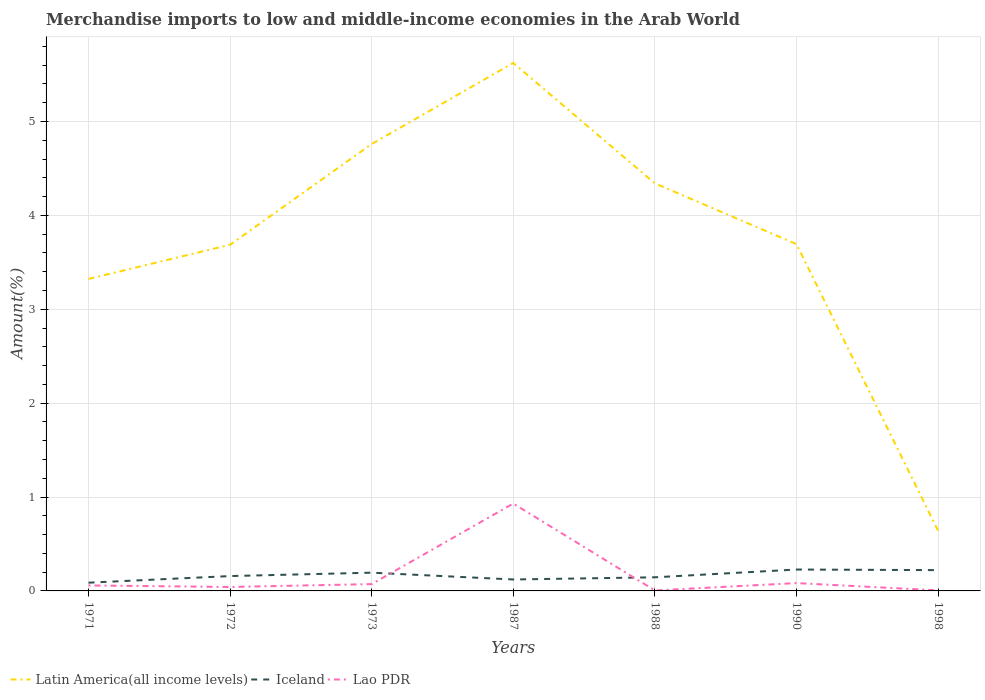Does the line corresponding to Iceland intersect with the line corresponding to Latin America(all income levels)?
Offer a very short reply. No. Across all years, what is the maximum percentage of amount earned from merchandise imports in Latin America(all income levels)?
Your response must be concise. 0.64. What is the total percentage of amount earned from merchandise imports in Lao PDR in the graph?
Your response must be concise. 0.04. What is the difference between the highest and the second highest percentage of amount earned from merchandise imports in Latin America(all income levels)?
Your answer should be compact. 4.98. Is the percentage of amount earned from merchandise imports in Latin America(all income levels) strictly greater than the percentage of amount earned from merchandise imports in Lao PDR over the years?
Keep it short and to the point. No. How many years are there in the graph?
Keep it short and to the point. 7. What is the difference between two consecutive major ticks on the Y-axis?
Make the answer very short. 1. Does the graph contain any zero values?
Keep it short and to the point. No. How are the legend labels stacked?
Give a very brief answer. Horizontal. What is the title of the graph?
Give a very brief answer. Merchandise imports to low and middle-income economies in the Arab World. Does "Mexico" appear as one of the legend labels in the graph?
Provide a short and direct response. No. What is the label or title of the X-axis?
Give a very brief answer. Years. What is the label or title of the Y-axis?
Your response must be concise. Amount(%). What is the Amount(%) of Latin America(all income levels) in 1971?
Give a very brief answer. 3.32. What is the Amount(%) of Iceland in 1971?
Provide a succinct answer. 0.09. What is the Amount(%) of Lao PDR in 1971?
Give a very brief answer. 0.06. What is the Amount(%) of Latin America(all income levels) in 1972?
Your answer should be compact. 3.69. What is the Amount(%) in Iceland in 1972?
Provide a succinct answer. 0.16. What is the Amount(%) in Lao PDR in 1972?
Offer a very short reply. 0.04. What is the Amount(%) of Latin America(all income levels) in 1973?
Provide a succinct answer. 4.76. What is the Amount(%) of Iceland in 1973?
Offer a very short reply. 0.19. What is the Amount(%) in Lao PDR in 1973?
Your answer should be compact. 0.07. What is the Amount(%) of Latin America(all income levels) in 1987?
Keep it short and to the point. 5.62. What is the Amount(%) in Iceland in 1987?
Your response must be concise. 0.12. What is the Amount(%) of Lao PDR in 1987?
Provide a succinct answer. 0.93. What is the Amount(%) in Latin America(all income levels) in 1988?
Ensure brevity in your answer.  4.34. What is the Amount(%) of Iceland in 1988?
Provide a short and direct response. 0.15. What is the Amount(%) of Lao PDR in 1988?
Provide a short and direct response. 0. What is the Amount(%) in Latin America(all income levels) in 1990?
Your answer should be compact. 3.69. What is the Amount(%) in Iceland in 1990?
Your response must be concise. 0.23. What is the Amount(%) in Lao PDR in 1990?
Your response must be concise. 0.08. What is the Amount(%) in Latin America(all income levels) in 1998?
Offer a terse response. 0.64. What is the Amount(%) in Iceland in 1998?
Your answer should be compact. 0.22. What is the Amount(%) in Lao PDR in 1998?
Offer a very short reply. 0.01. Across all years, what is the maximum Amount(%) of Latin America(all income levels)?
Your answer should be compact. 5.62. Across all years, what is the maximum Amount(%) of Iceland?
Offer a terse response. 0.23. Across all years, what is the maximum Amount(%) in Lao PDR?
Offer a terse response. 0.93. Across all years, what is the minimum Amount(%) in Latin America(all income levels)?
Your response must be concise. 0.64. Across all years, what is the minimum Amount(%) in Iceland?
Your answer should be compact. 0.09. Across all years, what is the minimum Amount(%) in Lao PDR?
Your answer should be compact. 0. What is the total Amount(%) in Latin America(all income levels) in the graph?
Provide a short and direct response. 26.07. What is the total Amount(%) of Iceland in the graph?
Your answer should be very brief. 1.16. What is the total Amount(%) of Lao PDR in the graph?
Provide a short and direct response. 1.2. What is the difference between the Amount(%) of Latin America(all income levels) in 1971 and that in 1972?
Give a very brief answer. -0.36. What is the difference between the Amount(%) of Iceland in 1971 and that in 1972?
Your answer should be very brief. -0.07. What is the difference between the Amount(%) in Lao PDR in 1971 and that in 1972?
Offer a very short reply. 0.02. What is the difference between the Amount(%) in Latin America(all income levels) in 1971 and that in 1973?
Give a very brief answer. -1.44. What is the difference between the Amount(%) of Iceland in 1971 and that in 1973?
Ensure brevity in your answer.  -0.11. What is the difference between the Amount(%) in Lao PDR in 1971 and that in 1973?
Provide a short and direct response. -0.01. What is the difference between the Amount(%) of Latin America(all income levels) in 1971 and that in 1987?
Provide a short and direct response. -2.3. What is the difference between the Amount(%) in Iceland in 1971 and that in 1987?
Offer a terse response. -0.03. What is the difference between the Amount(%) of Lao PDR in 1971 and that in 1987?
Your answer should be very brief. -0.87. What is the difference between the Amount(%) in Latin America(all income levels) in 1971 and that in 1988?
Keep it short and to the point. -1.02. What is the difference between the Amount(%) of Iceland in 1971 and that in 1988?
Provide a short and direct response. -0.06. What is the difference between the Amount(%) of Lao PDR in 1971 and that in 1988?
Your answer should be very brief. 0.05. What is the difference between the Amount(%) in Latin America(all income levels) in 1971 and that in 1990?
Offer a terse response. -0.37. What is the difference between the Amount(%) of Iceland in 1971 and that in 1990?
Your answer should be compact. -0.14. What is the difference between the Amount(%) of Lao PDR in 1971 and that in 1990?
Provide a succinct answer. -0.03. What is the difference between the Amount(%) in Latin America(all income levels) in 1971 and that in 1998?
Provide a succinct answer. 2.68. What is the difference between the Amount(%) of Iceland in 1971 and that in 1998?
Your answer should be very brief. -0.13. What is the difference between the Amount(%) in Lao PDR in 1971 and that in 1998?
Your answer should be compact. 0.05. What is the difference between the Amount(%) of Latin America(all income levels) in 1972 and that in 1973?
Your answer should be very brief. -1.07. What is the difference between the Amount(%) in Iceland in 1972 and that in 1973?
Provide a short and direct response. -0.04. What is the difference between the Amount(%) of Lao PDR in 1972 and that in 1973?
Keep it short and to the point. -0.03. What is the difference between the Amount(%) in Latin America(all income levels) in 1972 and that in 1987?
Provide a short and direct response. -1.94. What is the difference between the Amount(%) in Iceland in 1972 and that in 1987?
Your response must be concise. 0.04. What is the difference between the Amount(%) of Lao PDR in 1972 and that in 1987?
Keep it short and to the point. -0.89. What is the difference between the Amount(%) in Latin America(all income levels) in 1972 and that in 1988?
Ensure brevity in your answer.  -0.65. What is the difference between the Amount(%) in Iceland in 1972 and that in 1988?
Your answer should be very brief. 0.01. What is the difference between the Amount(%) in Lao PDR in 1972 and that in 1988?
Provide a succinct answer. 0.04. What is the difference between the Amount(%) in Latin America(all income levels) in 1972 and that in 1990?
Your answer should be very brief. -0.01. What is the difference between the Amount(%) of Iceland in 1972 and that in 1990?
Offer a terse response. -0.07. What is the difference between the Amount(%) in Lao PDR in 1972 and that in 1990?
Give a very brief answer. -0.04. What is the difference between the Amount(%) of Latin America(all income levels) in 1972 and that in 1998?
Your answer should be compact. 3.04. What is the difference between the Amount(%) of Iceland in 1972 and that in 1998?
Ensure brevity in your answer.  -0.06. What is the difference between the Amount(%) of Lao PDR in 1972 and that in 1998?
Give a very brief answer. 0.04. What is the difference between the Amount(%) in Latin America(all income levels) in 1973 and that in 1987?
Offer a terse response. -0.86. What is the difference between the Amount(%) of Iceland in 1973 and that in 1987?
Provide a short and direct response. 0.07. What is the difference between the Amount(%) of Lao PDR in 1973 and that in 1987?
Your answer should be compact. -0.86. What is the difference between the Amount(%) in Latin America(all income levels) in 1973 and that in 1988?
Keep it short and to the point. 0.42. What is the difference between the Amount(%) of Iceland in 1973 and that in 1988?
Keep it short and to the point. 0.05. What is the difference between the Amount(%) in Lao PDR in 1973 and that in 1988?
Your response must be concise. 0.07. What is the difference between the Amount(%) in Latin America(all income levels) in 1973 and that in 1990?
Offer a very short reply. 1.07. What is the difference between the Amount(%) in Iceland in 1973 and that in 1990?
Ensure brevity in your answer.  -0.03. What is the difference between the Amount(%) of Lao PDR in 1973 and that in 1990?
Make the answer very short. -0.01. What is the difference between the Amount(%) in Latin America(all income levels) in 1973 and that in 1998?
Provide a short and direct response. 4.12. What is the difference between the Amount(%) in Iceland in 1973 and that in 1998?
Your answer should be very brief. -0.03. What is the difference between the Amount(%) in Lao PDR in 1973 and that in 1998?
Give a very brief answer. 0.07. What is the difference between the Amount(%) in Latin America(all income levels) in 1987 and that in 1988?
Provide a succinct answer. 1.28. What is the difference between the Amount(%) in Iceland in 1987 and that in 1988?
Give a very brief answer. -0.02. What is the difference between the Amount(%) of Lao PDR in 1987 and that in 1988?
Keep it short and to the point. 0.93. What is the difference between the Amount(%) in Latin America(all income levels) in 1987 and that in 1990?
Your answer should be compact. 1.93. What is the difference between the Amount(%) in Iceland in 1987 and that in 1990?
Offer a very short reply. -0.11. What is the difference between the Amount(%) in Lao PDR in 1987 and that in 1990?
Ensure brevity in your answer.  0.85. What is the difference between the Amount(%) in Latin America(all income levels) in 1987 and that in 1998?
Provide a short and direct response. 4.98. What is the difference between the Amount(%) of Iceland in 1987 and that in 1998?
Offer a terse response. -0.1. What is the difference between the Amount(%) in Lao PDR in 1987 and that in 1998?
Provide a succinct answer. 0.92. What is the difference between the Amount(%) in Latin America(all income levels) in 1988 and that in 1990?
Your answer should be very brief. 0.65. What is the difference between the Amount(%) in Iceland in 1988 and that in 1990?
Provide a short and direct response. -0.08. What is the difference between the Amount(%) in Lao PDR in 1988 and that in 1990?
Offer a terse response. -0.08. What is the difference between the Amount(%) in Latin America(all income levels) in 1988 and that in 1998?
Your answer should be very brief. 3.7. What is the difference between the Amount(%) of Iceland in 1988 and that in 1998?
Keep it short and to the point. -0.08. What is the difference between the Amount(%) of Lao PDR in 1988 and that in 1998?
Your answer should be very brief. -0. What is the difference between the Amount(%) in Latin America(all income levels) in 1990 and that in 1998?
Provide a succinct answer. 3.05. What is the difference between the Amount(%) of Iceland in 1990 and that in 1998?
Offer a terse response. 0.01. What is the difference between the Amount(%) in Lao PDR in 1990 and that in 1998?
Provide a short and direct response. 0.08. What is the difference between the Amount(%) in Latin America(all income levels) in 1971 and the Amount(%) in Iceland in 1972?
Make the answer very short. 3.16. What is the difference between the Amount(%) of Latin America(all income levels) in 1971 and the Amount(%) of Lao PDR in 1972?
Give a very brief answer. 3.28. What is the difference between the Amount(%) in Iceland in 1971 and the Amount(%) in Lao PDR in 1972?
Make the answer very short. 0.05. What is the difference between the Amount(%) of Latin America(all income levels) in 1971 and the Amount(%) of Iceland in 1973?
Offer a very short reply. 3.13. What is the difference between the Amount(%) of Latin America(all income levels) in 1971 and the Amount(%) of Lao PDR in 1973?
Ensure brevity in your answer.  3.25. What is the difference between the Amount(%) of Iceland in 1971 and the Amount(%) of Lao PDR in 1973?
Your response must be concise. 0.01. What is the difference between the Amount(%) in Latin America(all income levels) in 1971 and the Amount(%) in Iceland in 1987?
Offer a very short reply. 3.2. What is the difference between the Amount(%) of Latin America(all income levels) in 1971 and the Amount(%) of Lao PDR in 1987?
Your answer should be very brief. 2.39. What is the difference between the Amount(%) of Iceland in 1971 and the Amount(%) of Lao PDR in 1987?
Ensure brevity in your answer.  -0.84. What is the difference between the Amount(%) in Latin America(all income levels) in 1971 and the Amount(%) in Iceland in 1988?
Make the answer very short. 3.18. What is the difference between the Amount(%) in Latin America(all income levels) in 1971 and the Amount(%) in Lao PDR in 1988?
Your response must be concise. 3.32. What is the difference between the Amount(%) in Iceland in 1971 and the Amount(%) in Lao PDR in 1988?
Offer a terse response. 0.08. What is the difference between the Amount(%) of Latin America(all income levels) in 1971 and the Amount(%) of Iceland in 1990?
Your answer should be very brief. 3.1. What is the difference between the Amount(%) in Latin America(all income levels) in 1971 and the Amount(%) in Lao PDR in 1990?
Ensure brevity in your answer.  3.24. What is the difference between the Amount(%) of Iceland in 1971 and the Amount(%) of Lao PDR in 1990?
Ensure brevity in your answer.  0. What is the difference between the Amount(%) in Latin America(all income levels) in 1971 and the Amount(%) in Iceland in 1998?
Give a very brief answer. 3.1. What is the difference between the Amount(%) in Latin America(all income levels) in 1971 and the Amount(%) in Lao PDR in 1998?
Keep it short and to the point. 3.32. What is the difference between the Amount(%) in Iceland in 1971 and the Amount(%) in Lao PDR in 1998?
Your response must be concise. 0.08. What is the difference between the Amount(%) of Latin America(all income levels) in 1972 and the Amount(%) of Iceland in 1973?
Provide a succinct answer. 3.49. What is the difference between the Amount(%) in Latin America(all income levels) in 1972 and the Amount(%) in Lao PDR in 1973?
Your answer should be very brief. 3.61. What is the difference between the Amount(%) of Iceland in 1972 and the Amount(%) of Lao PDR in 1973?
Provide a short and direct response. 0.09. What is the difference between the Amount(%) in Latin America(all income levels) in 1972 and the Amount(%) in Iceland in 1987?
Provide a succinct answer. 3.57. What is the difference between the Amount(%) in Latin America(all income levels) in 1972 and the Amount(%) in Lao PDR in 1987?
Your answer should be compact. 2.76. What is the difference between the Amount(%) in Iceland in 1972 and the Amount(%) in Lao PDR in 1987?
Give a very brief answer. -0.77. What is the difference between the Amount(%) of Latin America(all income levels) in 1972 and the Amount(%) of Iceland in 1988?
Offer a very short reply. 3.54. What is the difference between the Amount(%) in Latin America(all income levels) in 1972 and the Amount(%) in Lao PDR in 1988?
Your answer should be compact. 3.68. What is the difference between the Amount(%) of Iceland in 1972 and the Amount(%) of Lao PDR in 1988?
Your answer should be very brief. 0.15. What is the difference between the Amount(%) in Latin America(all income levels) in 1972 and the Amount(%) in Iceland in 1990?
Give a very brief answer. 3.46. What is the difference between the Amount(%) in Latin America(all income levels) in 1972 and the Amount(%) in Lao PDR in 1990?
Provide a succinct answer. 3.6. What is the difference between the Amount(%) in Iceland in 1972 and the Amount(%) in Lao PDR in 1990?
Your answer should be compact. 0.07. What is the difference between the Amount(%) in Latin America(all income levels) in 1972 and the Amount(%) in Iceland in 1998?
Provide a short and direct response. 3.47. What is the difference between the Amount(%) in Latin America(all income levels) in 1972 and the Amount(%) in Lao PDR in 1998?
Offer a very short reply. 3.68. What is the difference between the Amount(%) of Iceland in 1972 and the Amount(%) of Lao PDR in 1998?
Your response must be concise. 0.15. What is the difference between the Amount(%) of Latin America(all income levels) in 1973 and the Amount(%) of Iceland in 1987?
Make the answer very short. 4.64. What is the difference between the Amount(%) of Latin America(all income levels) in 1973 and the Amount(%) of Lao PDR in 1987?
Keep it short and to the point. 3.83. What is the difference between the Amount(%) of Iceland in 1973 and the Amount(%) of Lao PDR in 1987?
Offer a terse response. -0.74. What is the difference between the Amount(%) of Latin America(all income levels) in 1973 and the Amount(%) of Iceland in 1988?
Your answer should be compact. 4.62. What is the difference between the Amount(%) of Latin America(all income levels) in 1973 and the Amount(%) of Lao PDR in 1988?
Offer a terse response. 4.76. What is the difference between the Amount(%) of Iceland in 1973 and the Amount(%) of Lao PDR in 1988?
Ensure brevity in your answer.  0.19. What is the difference between the Amount(%) of Latin America(all income levels) in 1973 and the Amount(%) of Iceland in 1990?
Give a very brief answer. 4.53. What is the difference between the Amount(%) of Latin America(all income levels) in 1973 and the Amount(%) of Lao PDR in 1990?
Provide a succinct answer. 4.68. What is the difference between the Amount(%) of Iceland in 1973 and the Amount(%) of Lao PDR in 1990?
Your answer should be very brief. 0.11. What is the difference between the Amount(%) in Latin America(all income levels) in 1973 and the Amount(%) in Iceland in 1998?
Ensure brevity in your answer.  4.54. What is the difference between the Amount(%) in Latin America(all income levels) in 1973 and the Amount(%) in Lao PDR in 1998?
Your response must be concise. 4.75. What is the difference between the Amount(%) of Iceland in 1973 and the Amount(%) of Lao PDR in 1998?
Your answer should be compact. 0.19. What is the difference between the Amount(%) in Latin America(all income levels) in 1987 and the Amount(%) in Iceland in 1988?
Offer a very short reply. 5.48. What is the difference between the Amount(%) in Latin America(all income levels) in 1987 and the Amount(%) in Lao PDR in 1988?
Your answer should be compact. 5.62. What is the difference between the Amount(%) of Iceland in 1987 and the Amount(%) of Lao PDR in 1988?
Keep it short and to the point. 0.12. What is the difference between the Amount(%) of Latin America(all income levels) in 1987 and the Amount(%) of Iceland in 1990?
Ensure brevity in your answer.  5.4. What is the difference between the Amount(%) of Latin America(all income levels) in 1987 and the Amount(%) of Lao PDR in 1990?
Make the answer very short. 5.54. What is the difference between the Amount(%) in Iceland in 1987 and the Amount(%) in Lao PDR in 1990?
Make the answer very short. 0.04. What is the difference between the Amount(%) in Latin America(all income levels) in 1987 and the Amount(%) in Iceland in 1998?
Make the answer very short. 5.4. What is the difference between the Amount(%) of Latin America(all income levels) in 1987 and the Amount(%) of Lao PDR in 1998?
Offer a very short reply. 5.62. What is the difference between the Amount(%) in Iceland in 1987 and the Amount(%) in Lao PDR in 1998?
Your answer should be compact. 0.12. What is the difference between the Amount(%) of Latin America(all income levels) in 1988 and the Amount(%) of Iceland in 1990?
Provide a succinct answer. 4.11. What is the difference between the Amount(%) in Latin America(all income levels) in 1988 and the Amount(%) in Lao PDR in 1990?
Your response must be concise. 4.26. What is the difference between the Amount(%) in Iceland in 1988 and the Amount(%) in Lao PDR in 1990?
Your answer should be very brief. 0.06. What is the difference between the Amount(%) of Latin America(all income levels) in 1988 and the Amount(%) of Iceland in 1998?
Ensure brevity in your answer.  4.12. What is the difference between the Amount(%) of Latin America(all income levels) in 1988 and the Amount(%) of Lao PDR in 1998?
Keep it short and to the point. 4.34. What is the difference between the Amount(%) in Iceland in 1988 and the Amount(%) in Lao PDR in 1998?
Offer a terse response. 0.14. What is the difference between the Amount(%) in Latin America(all income levels) in 1990 and the Amount(%) in Iceland in 1998?
Your answer should be very brief. 3.47. What is the difference between the Amount(%) in Latin America(all income levels) in 1990 and the Amount(%) in Lao PDR in 1998?
Keep it short and to the point. 3.69. What is the difference between the Amount(%) of Iceland in 1990 and the Amount(%) of Lao PDR in 1998?
Offer a terse response. 0.22. What is the average Amount(%) of Latin America(all income levels) per year?
Your answer should be very brief. 3.72. What is the average Amount(%) in Iceland per year?
Your answer should be very brief. 0.17. What is the average Amount(%) in Lao PDR per year?
Keep it short and to the point. 0.17. In the year 1971, what is the difference between the Amount(%) in Latin America(all income levels) and Amount(%) in Iceland?
Provide a succinct answer. 3.24. In the year 1971, what is the difference between the Amount(%) of Latin America(all income levels) and Amount(%) of Lao PDR?
Your answer should be very brief. 3.26. In the year 1971, what is the difference between the Amount(%) in Iceland and Amount(%) in Lao PDR?
Your answer should be very brief. 0.03. In the year 1972, what is the difference between the Amount(%) in Latin America(all income levels) and Amount(%) in Iceland?
Ensure brevity in your answer.  3.53. In the year 1972, what is the difference between the Amount(%) of Latin America(all income levels) and Amount(%) of Lao PDR?
Your answer should be compact. 3.65. In the year 1972, what is the difference between the Amount(%) in Iceland and Amount(%) in Lao PDR?
Your answer should be very brief. 0.12. In the year 1973, what is the difference between the Amount(%) in Latin America(all income levels) and Amount(%) in Iceland?
Offer a terse response. 4.57. In the year 1973, what is the difference between the Amount(%) of Latin America(all income levels) and Amount(%) of Lao PDR?
Your response must be concise. 4.69. In the year 1973, what is the difference between the Amount(%) in Iceland and Amount(%) in Lao PDR?
Provide a short and direct response. 0.12. In the year 1987, what is the difference between the Amount(%) of Latin America(all income levels) and Amount(%) of Iceland?
Give a very brief answer. 5.5. In the year 1987, what is the difference between the Amount(%) of Latin America(all income levels) and Amount(%) of Lao PDR?
Offer a very short reply. 4.69. In the year 1987, what is the difference between the Amount(%) in Iceland and Amount(%) in Lao PDR?
Your response must be concise. -0.81. In the year 1988, what is the difference between the Amount(%) in Latin America(all income levels) and Amount(%) in Iceland?
Provide a succinct answer. 4.2. In the year 1988, what is the difference between the Amount(%) in Latin America(all income levels) and Amount(%) in Lao PDR?
Your answer should be very brief. 4.34. In the year 1988, what is the difference between the Amount(%) of Iceland and Amount(%) of Lao PDR?
Keep it short and to the point. 0.14. In the year 1990, what is the difference between the Amount(%) in Latin America(all income levels) and Amount(%) in Iceland?
Ensure brevity in your answer.  3.47. In the year 1990, what is the difference between the Amount(%) in Latin America(all income levels) and Amount(%) in Lao PDR?
Your response must be concise. 3.61. In the year 1990, what is the difference between the Amount(%) of Iceland and Amount(%) of Lao PDR?
Ensure brevity in your answer.  0.14. In the year 1998, what is the difference between the Amount(%) in Latin America(all income levels) and Amount(%) in Iceland?
Offer a very short reply. 0.42. In the year 1998, what is the difference between the Amount(%) in Latin America(all income levels) and Amount(%) in Lao PDR?
Ensure brevity in your answer.  0.64. In the year 1998, what is the difference between the Amount(%) in Iceland and Amount(%) in Lao PDR?
Provide a short and direct response. 0.22. What is the ratio of the Amount(%) of Latin America(all income levels) in 1971 to that in 1972?
Offer a terse response. 0.9. What is the ratio of the Amount(%) in Iceland in 1971 to that in 1972?
Provide a short and direct response. 0.55. What is the ratio of the Amount(%) of Lao PDR in 1971 to that in 1972?
Offer a terse response. 1.39. What is the ratio of the Amount(%) in Latin America(all income levels) in 1971 to that in 1973?
Offer a very short reply. 0.7. What is the ratio of the Amount(%) in Iceland in 1971 to that in 1973?
Offer a terse response. 0.45. What is the ratio of the Amount(%) of Lao PDR in 1971 to that in 1973?
Make the answer very short. 0.8. What is the ratio of the Amount(%) of Latin America(all income levels) in 1971 to that in 1987?
Your response must be concise. 0.59. What is the ratio of the Amount(%) in Iceland in 1971 to that in 1987?
Make the answer very short. 0.72. What is the ratio of the Amount(%) in Lao PDR in 1971 to that in 1987?
Offer a terse response. 0.06. What is the ratio of the Amount(%) of Latin America(all income levels) in 1971 to that in 1988?
Your answer should be compact. 0.77. What is the ratio of the Amount(%) of Iceland in 1971 to that in 1988?
Your answer should be compact. 0.61. What is the ratio of the Amount(%) of Lao PDR in 1971 to that in 1988?
Your answer should be very brief. 11.95. What is the ratio of the Amount(%) of Latin America(all income levels) in 1971 to that in 1990?
Your response must be concise. 0.9. What is the ratio of the Amount(%) in Iceland in 1971 to that in 1990?
Your response must be concise. 0.39. What is the ratio of the Amount(%) of Lao PDR in 1971 to that in 1990?
Offer a terse response. 0.7. What is the ratio of the Amount(%) of Latin America(all income levels) in 1971 to that in 1998?
Give a very brief answer. 5.17. What is the ratio of the Amount(%) of Iceland in 1971 to that in 1998?
Provide a succinct answer. 0.4. What is the ratio of the Amount(%) of Lao PDR in 1971 to that in 1998?
Offer a terse response. 9.8. What is the ratio of the Amount(%) of Latin America(all income levels) in 1972 to that in 1973?
Make the answer very short. 0.77. What is the ratio of the Amount(%) in Iceland in 1972 to that in 1973?
Keep it short and to the point. 0.81. What is the ratio of the Amount(%) in Lao PDR in 1972 to that in 1973?
Provide a succinct answer. 0.58. What is the ratio of the Amount(%) in Latin America(all income levels) in 1972 to that in 1987?
Ensure brevity in your answer.  0.66. What is the ratio of the Amount(%) of Iceland in 1972 to that in 1987?
Your answer should be compact. 1.3. What is the ratio of the Amount(%) in Lao PDR in 1972 to that in 1987?
Keep it short and to the point. 0.05. What is the ratio of the Amount(%) in Latin America(all income levels) in 1972 to that in 1988?
Give a very brief answer. 0.85. What is the ratio of the Amount(%) of Iceland in 1972 to that in 1988?
Make the answer very short. 1.09. What is the ratio of the Amount(%) in Lao PDR in 1972 to that in 1988?
Your answer should be compact. 8.59. What is the ratio of the Amount(%) of Iceland in 1972 to that in 1990?
Your answer should be compact. 0.69. What is the ratio of the Amount(%) of Lao PDR in 1972 to that in 1990?
Make the answer very short. 0.5. What is the ratio of the Amount(%) in Latin America(all income levels) in 1972 to that in 1998?
Give a very brief answer. 5.74. What is the ratio of the Amount(%) of Iceland in 1972 to that in 1998?
Keep it short and to the point. 0.71. What is the ratio of the Amount(%) in Lao PDR in 1972 to that in 1998?
Offer a terse response. 7.04. What is the ratio of the Amount(%) in Latin America(all income levels) in 1973 to that in 1987?
Provide a short and direct response. 0.85. What is the ratio of the Amount(%) in Iceland in 1973 to that in 1987?
Ensure brevity in your answer.  1.59. What is the ratio of the Amount(%) of Lao PDR in 1973 to that in 1987?
Provide a short and direct response. 0.08. What is the ratio of the Amount(%) in Latin America(all income levels) in 1973 to that in 1988?
Offer a terse response. 1.1. What is the ratio of the Amount(%) in Iceland in 1973 to that in 1988?
Offer a very short reply. 1.34. What is the ratio of the Amount(%) of Lao PDR in 1973 to that in 1988?
Make the answer very short. 14.89. What is the ratio of the Amount(%) of Latin America(all income levels) in 1973 to that in 1990?
Your answer should be compact. 1.29. What is the ratio of the Amount(%) of Iceland in 1973 to that in 1990?
Your answer should be very brief. 0.85. What is the ratio of the Amount(%) in Lao PDR in 1973 to that in 1990?
Make the answer very short. 0.87. What is the ratio of the Amount(%) of Latin America(all income levels) in 1973 to that in 1998?
Keep it short and to the point. 7.41. What is the ratio of the Amount(%) in Iceland in 1973 to that in 1998?
Your answer should be compact. 0.88. What is the ratio of the Amount(%) in Lao PDR in 1973 to that in 1998?
Ensure brevity in your answer.  12.21. What is the ratio of the Amount(%) in Latin America(all income levels) in 1987 to that in 1988?
Your answer should be compact. 1.3. What is the ratio of the Amount(%) in Iceland in 1987 to that in 1988?
Offer a terse response. 0.84. What is the ratio of the Amount(%) of Lao PDR in 1987 to that in 1988?
Provide a short and direct response. 190.5. What is the ratio of the Amount(%) in Latin America(all income levels) in 1987 to that in 1990?
Your response must be concise. 1.52. What is the ratio of the Amount(%) of Iceland in 1987 to that in 1990?
Provide a succinct answer. 0.54. What is the ratio of the Amount(%) of Lao PDR in 1987 to that in 1990?
Provide a short and direct response. 11.16. What is the ratio of the Amount(%) of Latin America(all income levels) in 1987 to that in 1998?
Provide a succinct answer. 8.75. What is the ratio of the Amount(%) in Iceland in 1987 to that in 1998?
Offer a terse response. 0.55. What is the ratio of the Amount(%) of Lao PDR in 1987 to that in 1998?
Provide a succinct answer. 156.24. What is the ratio of the Amount(%) of Latin America(all income levels) in 1988 to that in 1990?
Give a very brief answer. 1.18. What is the ratio of the Amount(%) in Iceland in 1988 to that in 1990?
Make the answer very short. 0.64. What is the ratio of the Amount(%) in Lao PDR in 1988 to that in 1990?
Offer a very short reply. 0.06. What is the ratio of the Amount(%) of Latin America(all income levels) in 1988 to that in 1998?
Provide a short and direct response. 6.75. What is the ratio of the Amount(%) in Iceland in 1988 to that in 1998?
Your answer should be compact. 0.66. What is the ratio of the Amount(%) of Lao PDR in 1988 to that in 1998?
Offer a terse response. 0.82. What is the ratio of the Amount(%) of Latin America(all income levels) in 1990 to that in 1998?
Offer a terse response. 5.75. What is the ratio of the Amount(%) in Iceland in 1990 to that in 1998?
Offer a terse response. 1.03. What is the ratio of the Amount(%) of Lao PDR in 1990 to that in 1998?
Provide a succinct answer. 14. What is the difference between the highest and the second highest Amount(%) of Latin America(all income levels)?
Provide a succinct answer. 0.86. What is the difference between the highest and the second highest Amount(%) of Iceland?
Offer a terse response. 0.01. What is the difference between the highest and the second highest Amount(%) of Lao PDR?
Make the answer very short. 0.85. What is the difference between the highest and the lowest Amount(%) of Latin America(all income levels)?
Offer a terse response. 4.98. What is the difference between the highest and the lowest Amount(%) in Iceland?
Give a very brief answer. 0.14. What is the difference between the highest and the lowest Amount(%) in Lao PDR?
Give a very brief answer. 0.93. 